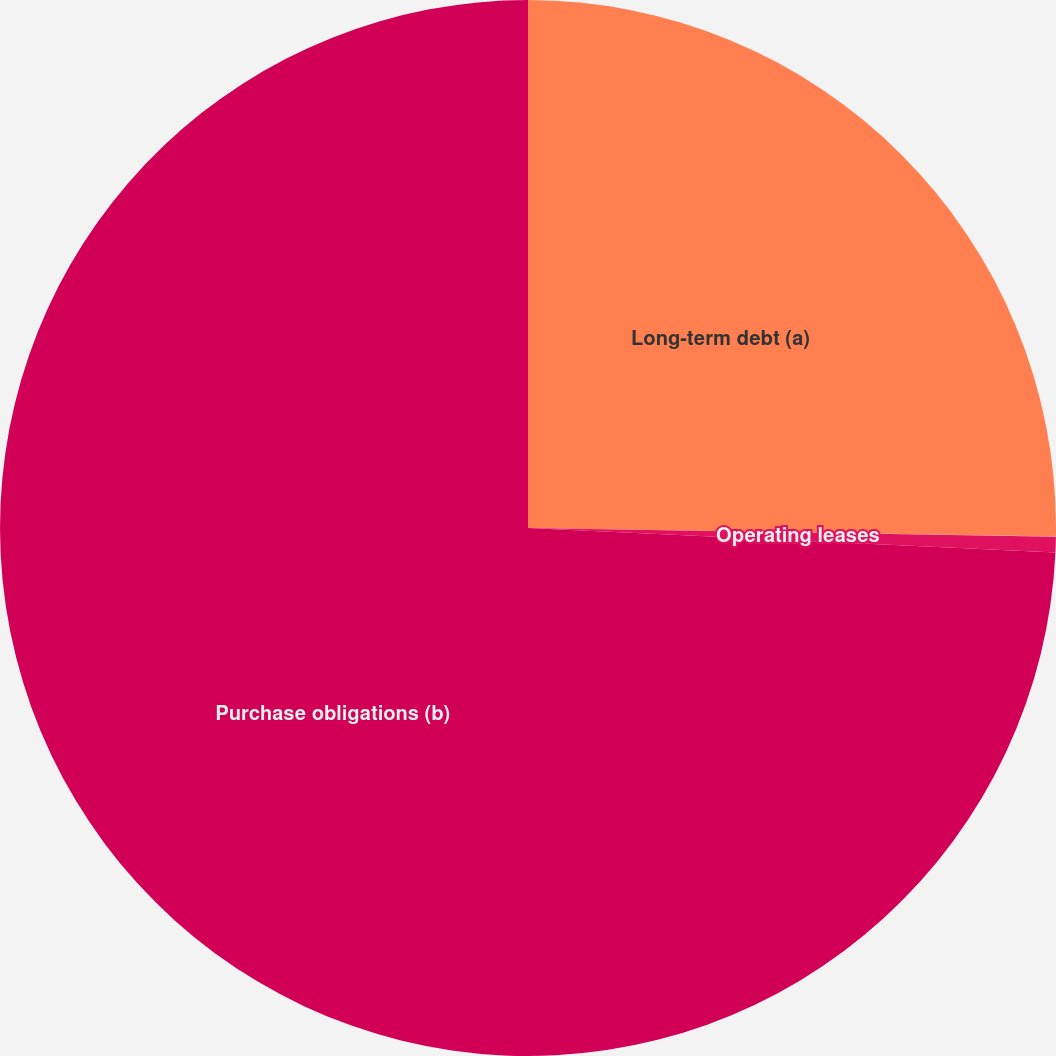Convert chart to OTSL. <chart><loc_0><loc_0><loc_500><loc_500><pie_chart><fcel>Long-term debt (a)<fcel>Operating leases<fcel>Purchase obligations (b)<nl><fcel>25.26%<fcel>0.48%<fcel>74.26%<nl></chart> 